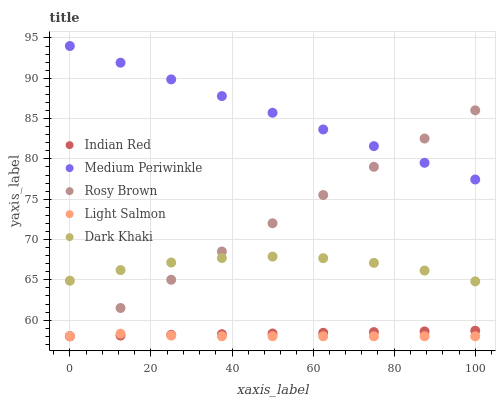Does Light Salmon have the minimum area under the curve?
Answer yes or no. Yes. Does Medium Periwinkle have the maximum area under the curve?
Answer yes or no. Yes. Does Rosy Brown have the minimum area under the curve?
Answer yes or no. No. Does Rosy Brown have the maximum area under the curve?
Answer yes or no. No. Is Indian Red the smoothest?
Answer yes or no. Yes. Is Dark Khaki the roughest?
Answer yes or no. Yes. Is Light Salmon the smoothest?
Answer yes or no. No. Is Light Salmon the roughest?
Answer yes or no. No. Does Light Salmon have the lowest value?
Answer yes or no. Yes. Does Medium Periwinkle have the lowest value?
Answer yes or no. No. Does Medium Periwinkle have the highest value?
Answer yes or no. Yes. Does Rosy Brown have the highest value?
Answer yes or no. No. Is Indian Red less than Dark Khaki?
Answer yes or no. Yes. Is Medium Periwinkle greater than Dark Khaki?
Answer yes or no. Yes. Does Indian Red intersect Light Salmon?
Answer yes or no. Yes. Is Indian Red less than Light Salmon?
Answer yes or no. No. Is Indian Red greater than Light Salmon?
Answer yes or no. No. Does Indian Red intersect Dark Khaki?
Answer yes or no. No. 